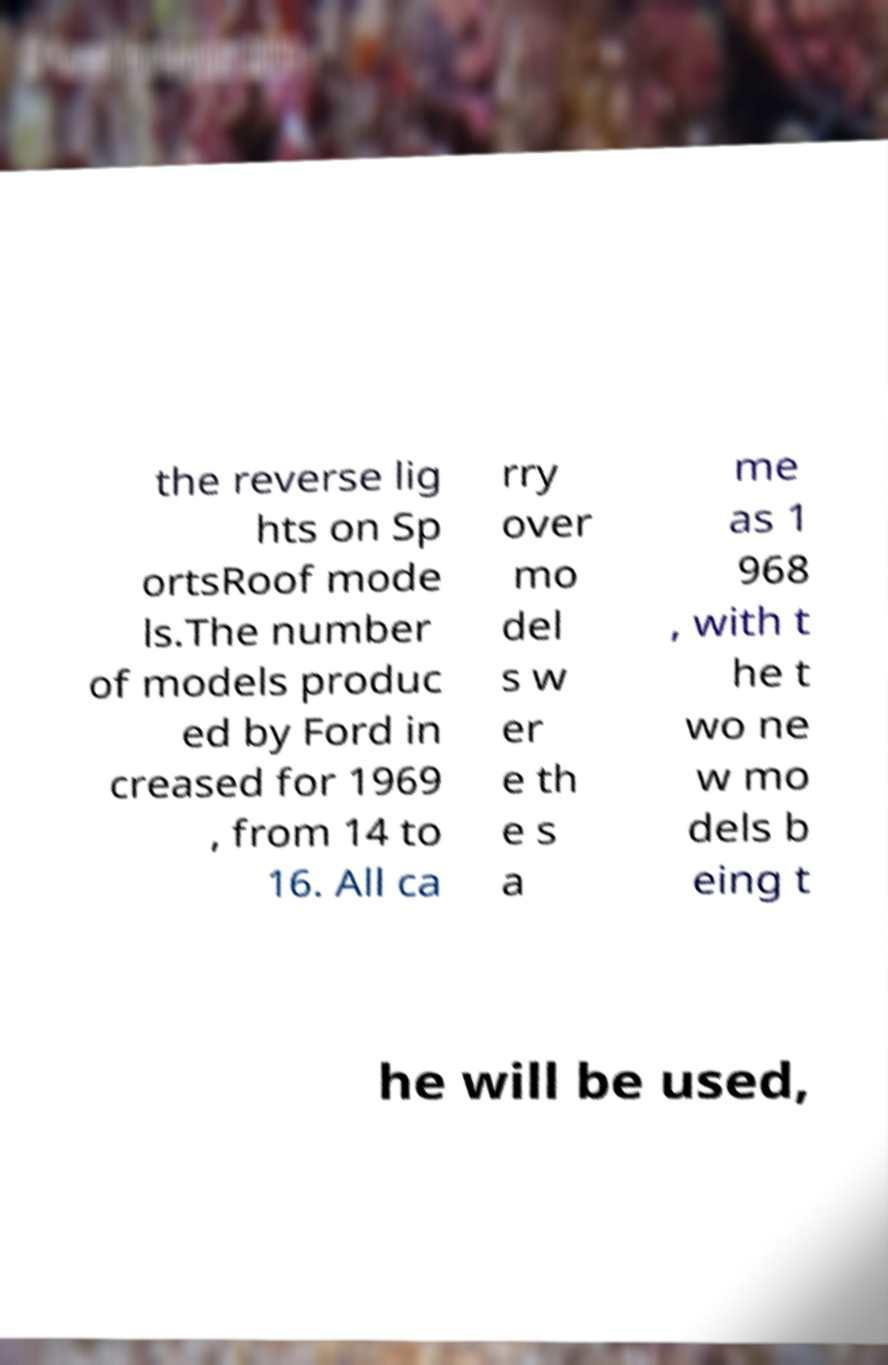Could you extract and type out the text from this image? the reverse lig hts on Sp ortsRoof mode ls.The number of models produc ed by Ford in creased for 1969 , from 14 to 16. All ca rry over mo del s w er e th e s a me as 1 968 , with t he t wo ne w mo dels b eing t he will be used, 